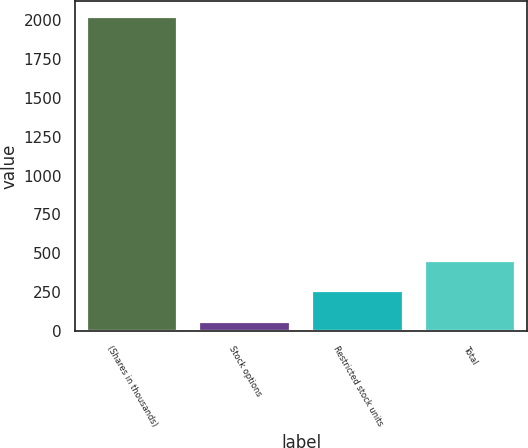Convert chart. <chart><loc_0><loc_0><loc_500><loc_500><bar_chart><fcel>(Shares in thousands)<fcel>Stock options<fcel>Restricted stock units<fcel>Total<nl><fcel>2018<fcel>59<fcel>254.9<fcel>450.8<nl></chart> 